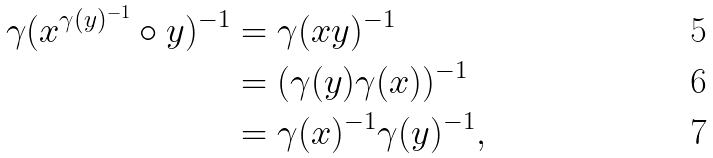Convert formula to latex. <formula><loc_0><loc_0><loc_500><loc_500>\gamma ( x ^ { \gamma ( y ) ^ { - 1 } } \circ y ) ^ { - 1 } & = \gamma ( x y ) ^ { - 1 } \\ & = ( \gamma ( y ) \gamma ( x ) ) ^ { - 1 } \\ & = \gamma ( x ) ^ { - 1 } \gamma ( y ) ^ { - 1 } ,</formula> 